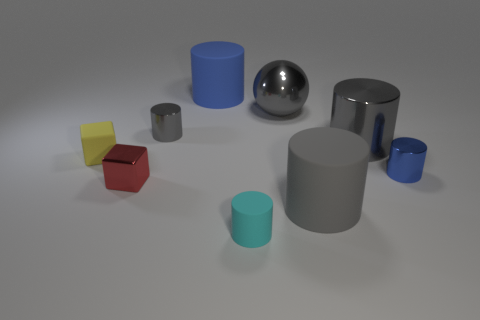Is there any other thing that has the same material as the tiny red block?
Make the answer very short. Yes. How many other things are the same shape as the yellow rubber thing?
Ensure brevity in your answer.  1. Is the yellow object the same shape as the red metallic object?
Your answer should be compact. Yes. Are there any large blue objects right of the small cyan matte cylinder?
Give a very brief answer. No. What number of things are large balls or gray rubber objects?
Give a very brief answer. 2. What number of other things are the same size as the blue matte thing?
Your response must be concise. 3. How many things are both behind the large gray matte object and to the right of the tiny gray metallic object?
Offer a very short reply. 4. There is a blue object in front of the sphere; is it the same size as the gray cylinder that is to the left of the large blue object?
Your answer should be very brief. Yes. There is a metallic cylinder that is to the left of the blue matte object; what size is it?
Offer a very short reply. Small. How many things are small gray metallic cylinders left of the small cyan object or tiny cylinders behind the tiny cyan matte object?
Your answer should be very brief. 2. 